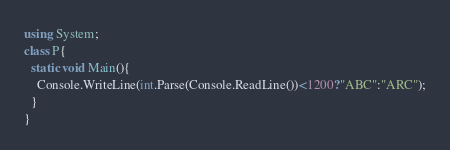<code> <loc_0><loc_0><loc_500><loc_500><_C#_>using System;
class P{
  static void Main(){
    Console.WriteLine(int.Parse(Console.ReadLine())<1200?"ABC":"ARC");
  }
}</code> 